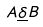Convert formula to latex. <formula><loc_0><loc_0><loc_500><loc_500>A \underline { \delta } B</formula> 